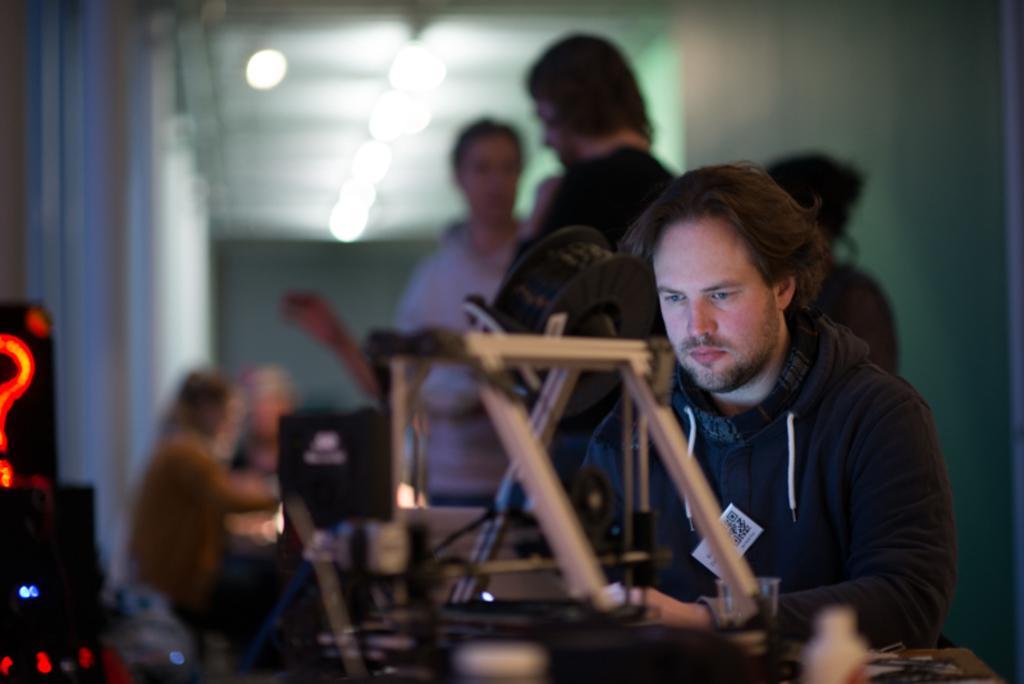Could you give a brief overview of what you see in this image? In this picture there are people in the center of the image and there are lights at the top side of the image. 